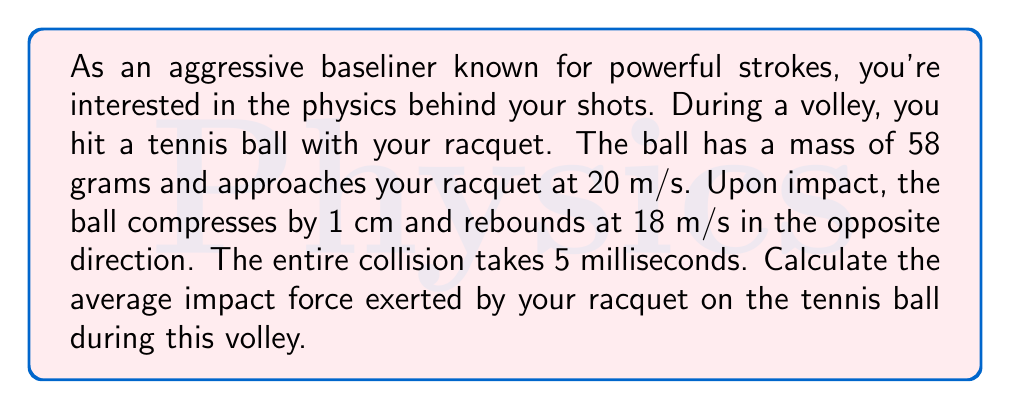Show me your answer to this math problem. To solve this problem, we'll use the impulse-momentum theorem and Newton's Second Law of Motion. Let's break it down step-by-step:

1) First, we need to calculate the change in momentum of the tennis ball:

   Initial velocity: $v_i = 20$ m/s (towards the racquet)
   Final velocity: $v_f = -18$ m/s (away from the racquet, hence negative)
   Mass of the ball: $m = 0.058$ kg

   Change in momentum: $\Delta p = m(v_f - v_i)$
   $$\Delta p = 0.058 \cdot (-18 - 20) = -2.204 \text{ kg}\cdot\text{m}/\text{s}$$

2) Now, we can use the impulse-momentum theorem:
   
   Impulse = Change in momentum
   $$F \cdot \Delta t = \Delta p$$

   Where $F$ is the average force and $\Delta t$ is the time of impact.

3) We're given that the collision takes 5 milliseconds, so $\Delta t = 0.005$ s

4) Rearranging the equation to solve for $F$:

   $$F = \frac{\Delta p}{\Delta t} = \frac{-2.204}{0.005} = -440.8 \text{ N}$$

5) The negative sign indicates that the force is in the opposite direction of the initial velocity, which is expected as the racquet is stopping and reversing the ball's motion.

6) To get the magnitude of the force, we take the absolute value:

   $$|F| = 440.8 \text{ N}$$

Therefore, the average impact force exerted by your racquet on the tennis ball during this volley is 440.8 N.
Answer: The average impact force is 440.8 N. 